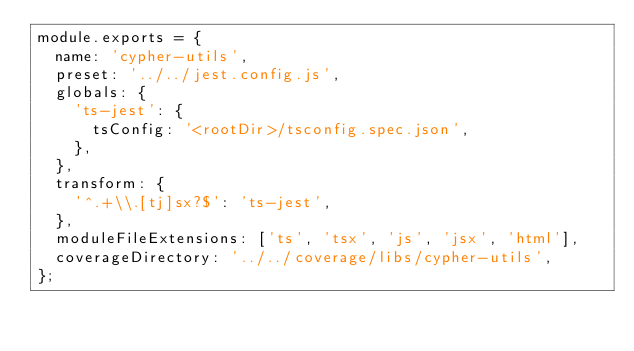<code> <loc_0><loc_0><loc_500><loc_500><_JavaScript_>module.exports = {
  name: 'cypher-utils',
  preset: '../../jest.config.js',
  globals: {
    'ts-jest': {
      tsConfig: '<rootDir>/tsconfig.spec.json',
    },
  },
  transform: {
    '^.+\\.[tj]sx?$': 'ts-jest',
  },
  moduleFileExtensions: ['ts', 'tsx', 'js', 'jsx', 'html'],
  coverageDirectory: '../../coverage/libs/cypher-utils',
};
</code> 